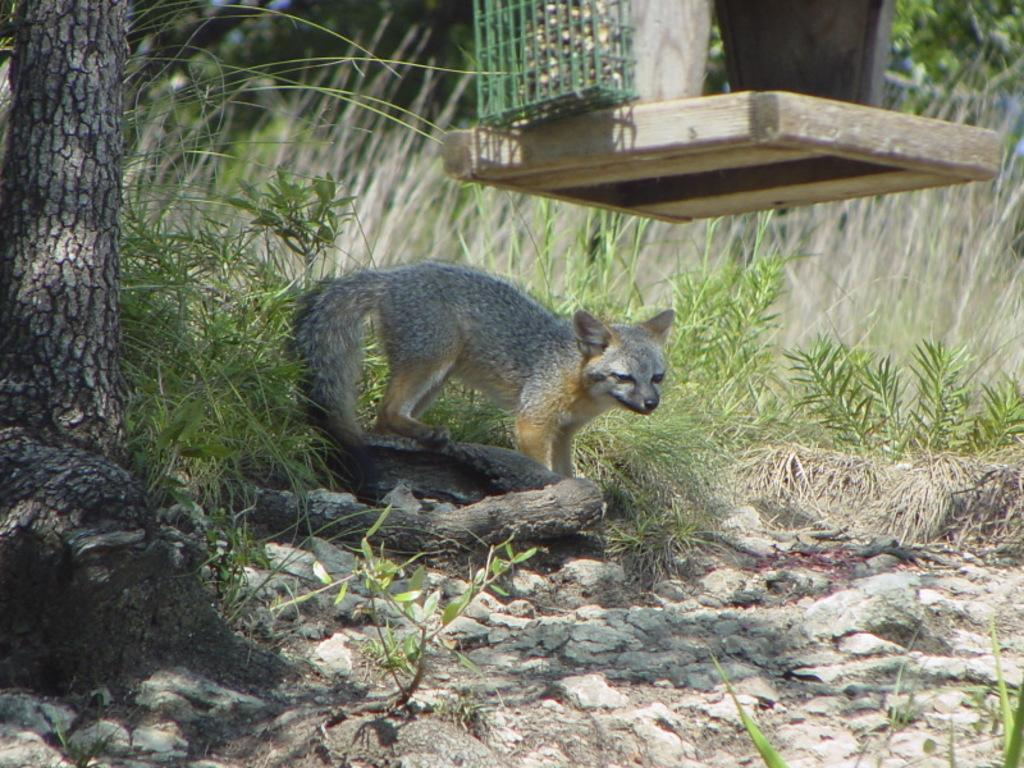What type of living organism is present in the image? There is an animal in the image. What other natural elements can be seen in the image? There are plants, a tree, and rocks visible in the image. What is the animal standing on in the image? There is a platform above the animal. What is covering the platform in the image? There is a mesh above the platform. How would you describe the background of the image? The background of the image is blurred. How many stems can be seen growing from the animal in the image? There are no stems growing from the animal in the image. 